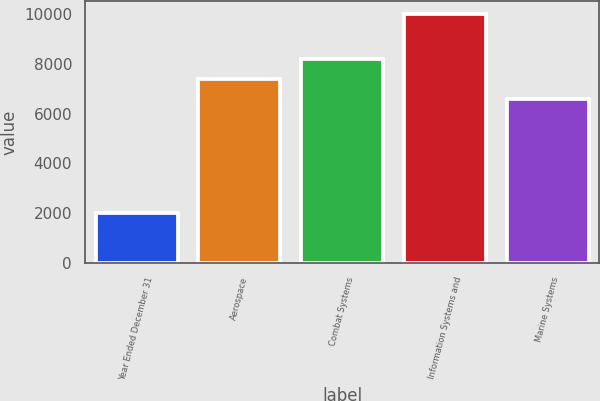<chart> <loc_0><loc_0><loc_500><loc_500><bar_chart><fcel>Year Ended December 31<fcel>Aerospace<fcel>Combat Systems<fcel>Information Systems and<fcel>Marine Systems<nl><fcel>2012<fcel>7392.5<fcel>8193<fcel>10017<fcel>6592<nl></chart> 